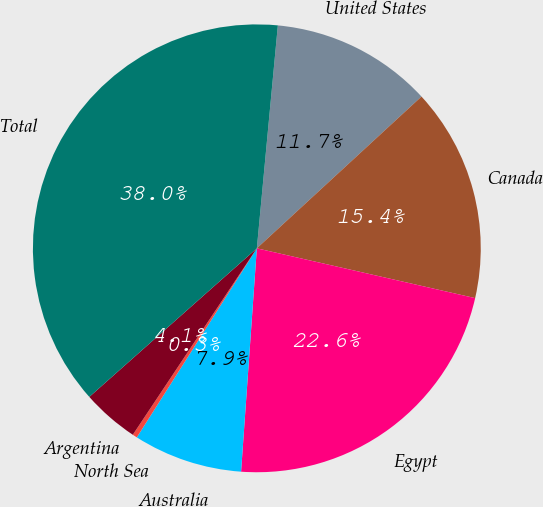Convert chart to OTSL. <chart><loc_0><loc_0><loc_500><loc_500><pie_chart><fcel>United States<fcel>Canada<fcel>Egypt<fcel>Australia<fcel>North Sea<fcel>Argentina<fcel>Total<nl><fcel>11.65%<fcel>15.42%<fcel>22.55%<fcel>7.88%<fcel>0.34%<fcel>4.11%<fcel>38.04%<nl></chart> 